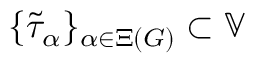Convert formula to latex. <formula><loc_0><loc_0><loc_500><loc_500>\{ \widetilde { \tau } _ { \alpha } \} _ { \alpha \in \Xi ( G ) } \subset \mathbb { V }</formula> 